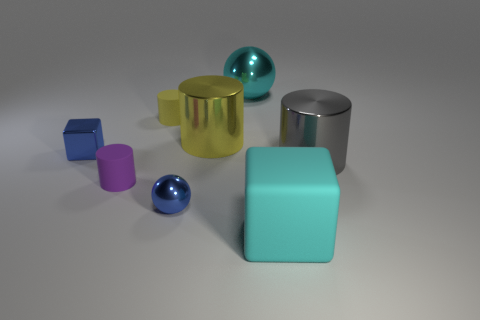Subtract all big yellow shiny cylinders. How many cylinders are left? 3 Subtract all gray balls. How many yellow cylinders are left? 2 Subtract all gray cylinders. How many cylinders are left? 3 Add 1 small objects. How many objects exist? 9 Subtract all cubes. How many objects are left? 6 Subtract all blue cylinders. Subtract all green spheres. How many cylinders are left? 4 Subtract all big gray matte things. Subtract all tiny blue things. How many objects are left? 6 Add 7 gray objects. How many gray objects are left? 8 Add 1 big blue metal cubes. How many big blue metal cubes exist? 1 Subtract 0 blue cylinders. How many objects are left? 8 